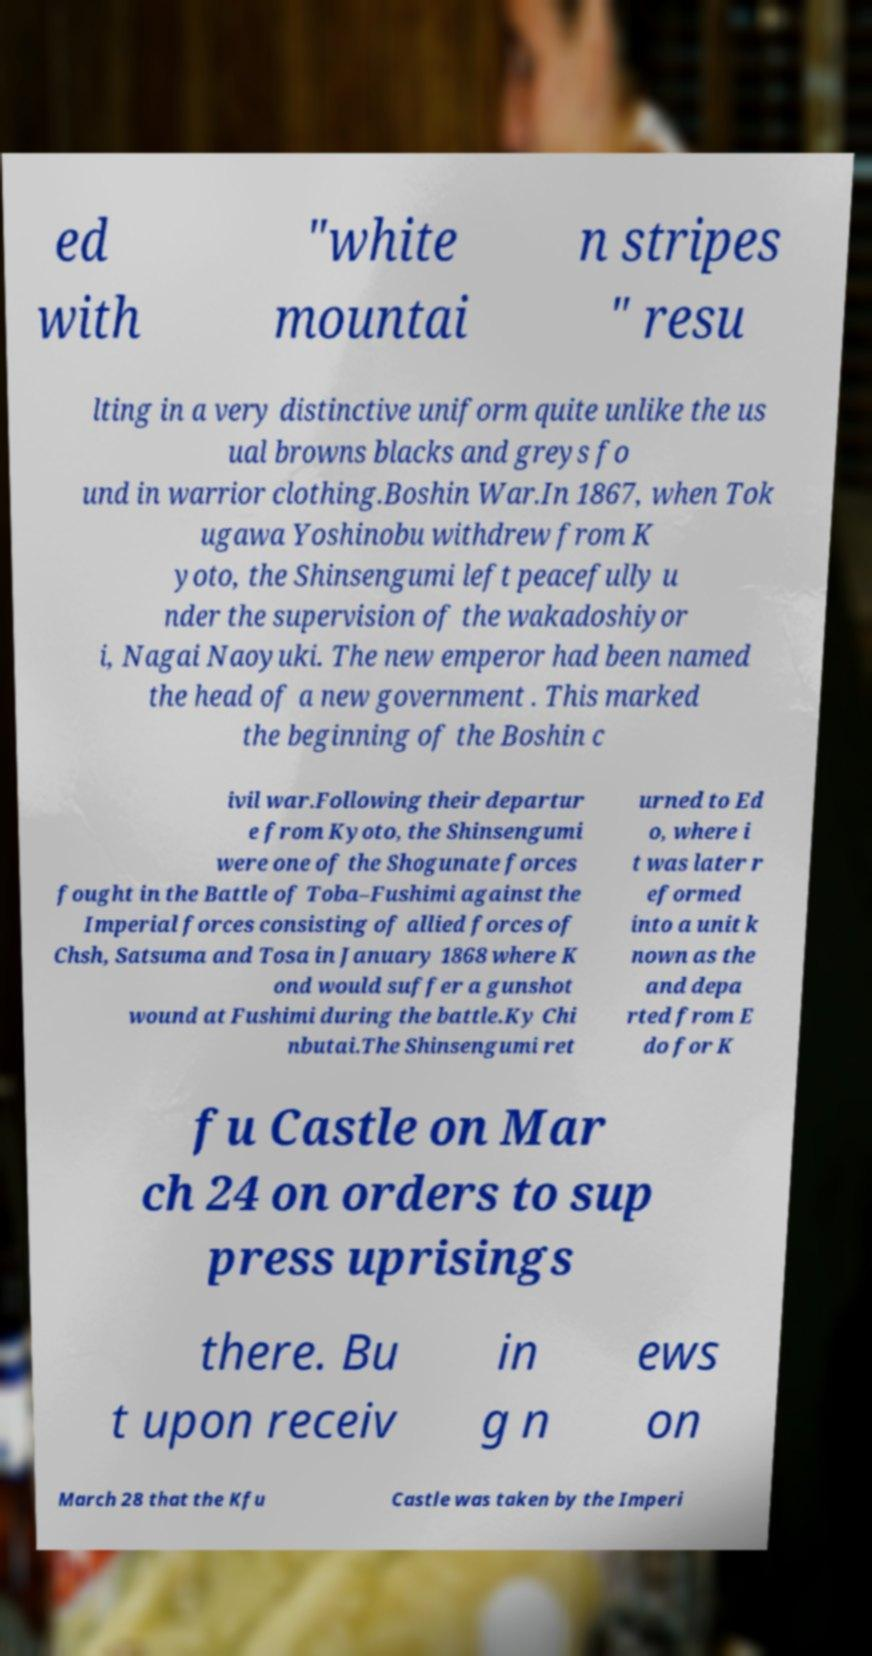For documentation purposes, I need the text within this image transcribed. Could you provide that? ed with "white mountai n stripes " resu lting in a very distinctive uniform quite unlike the us ual browns blacks and greys fo und in warrior clothing.Boshin War.In 1867, when Tok ugawa Yoshinobu withdrew from K yoto, the Shinsengumi left peacefully u nder the supervision of the wakadoshiyor i, Nagai Naoyuki. The new emperor had been named the head of a new government . This marked the beginning of the Boshin c ivil war.Following their departur e from Kyoto, the Shinsengumi were one of the Shogunate forces fought in the Battle of Toba–Fushimi against the Imperial forces consisting of allied forces of Chsh, Satsuma and Tosa in January 1868 where K ond would suffer a gunshot wound at Fushimi during the battle.Ky Chi nbutai.The Shinsengumi ret urned to Ed o, where i t was later r eformed into a unit k nown as the and depa rted from E do for K fu Castle on Mar ch 24 on orders to sup press uprisings there. Bu t upon receiv in g n ews on March 28 that the Kfu Castle was taken by the Imperi 